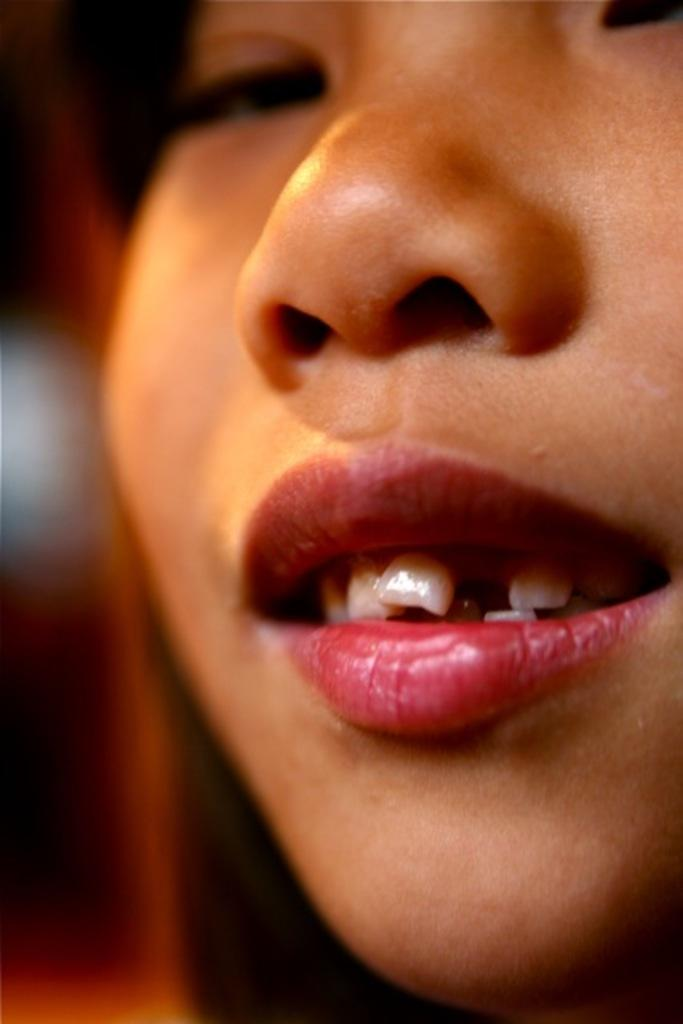What is the main subject of the image? There is a person's face in the image. Can you describe the background of the image? The background of the image is blurred. What type of care is the person providing to the snake in the image? There is no snake present in the image, so it is not possible to determine what type of care the person might be providing. 